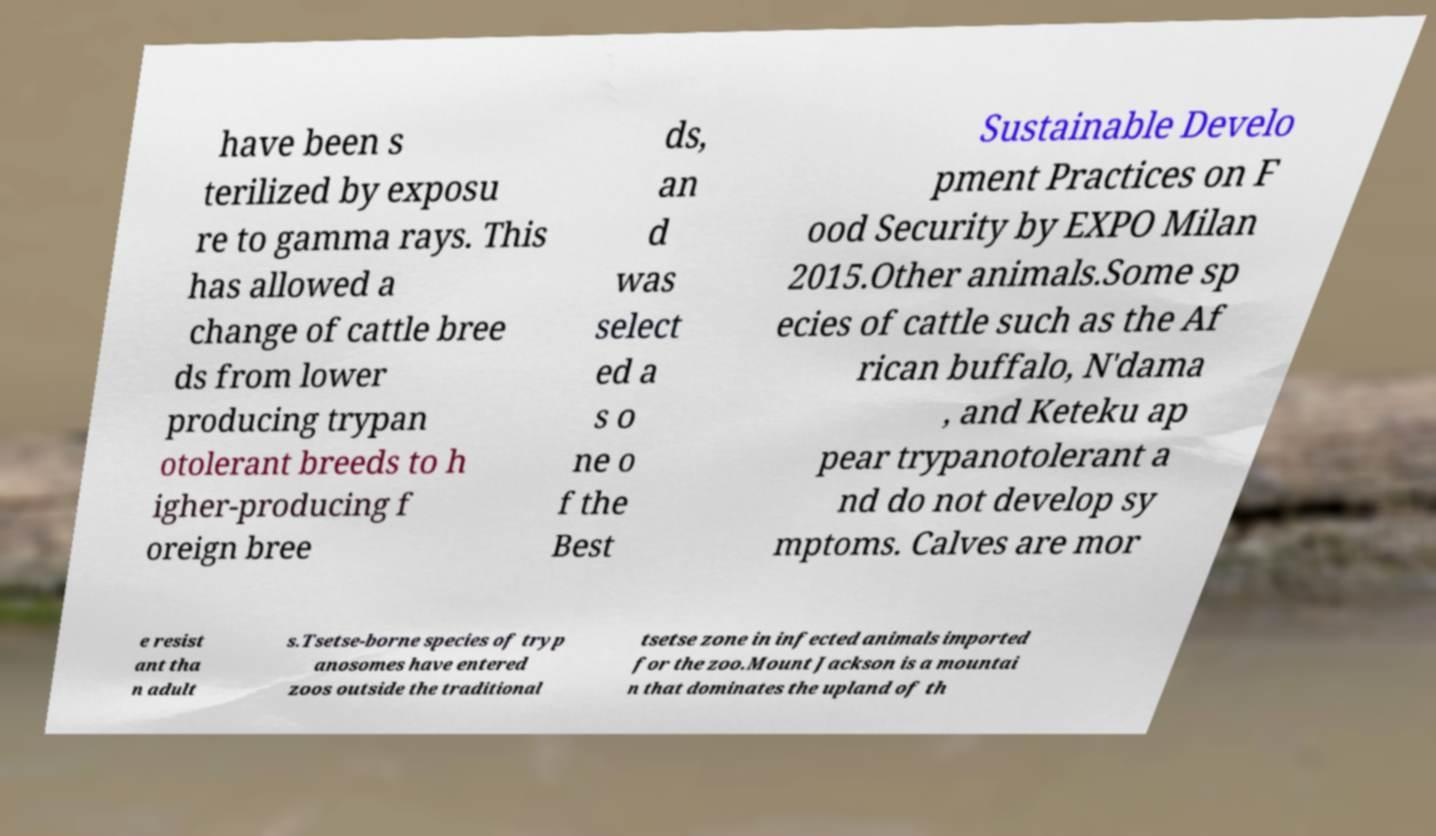Could you extract and type out the text from this image? have been s terilized by exposu re to gamma rays. This has allowed a change of cattle bree ds from lower producing trypan otolerant breeds to h igher-producing f oreign bree ds, an d was select ed a s o ne o f the Best Sustainable Develo pment Practices on F ood Security by EXPO Milan 2015.Other animals.Some sp ecies of cattle such as the Af rican buffalo, N'dama , and Keteku ap pear trypanotolerant a nd do not develop sy mptoms. Calves are mor e resist ant tha n adult s.Tsetse-borne species of tryp anosomes have entered zoos outside the traditional tsetse zone in infected animals imported for the zoo.Mount Jackson is a mountai n that dominates the upland of th 